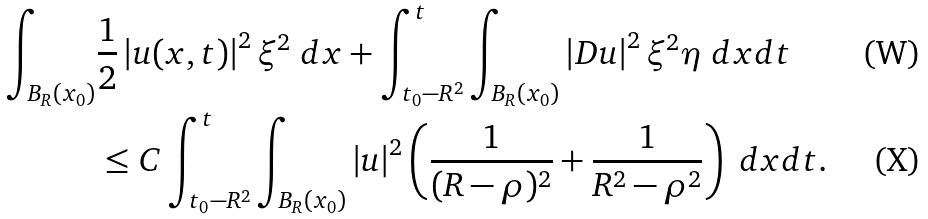Convert formula to latex. <formula><loc_0><loc_0><loc_500><loc_500>\int _ { B _ { R } ( x _ { 0 } ) } & \frac { 1 } { 2 } \left | u ( x , t ) \right | ^ { 2 } \xi ^ { 2 } \ d x + \int _ { t _ { 0 } - R ^ { 2 } } ^ { t } \int _ { B _ { R } ( x _ { 0 } ) } \left | D u \right | ^ { 2 } \xi ^ { 2 } \eta \ d x d t \\ & \leq C \int _ { t _ { 0 } - R ^ { 2 } } ^ { t } \int _ { B _ { R } ( x _ { 0 } ) } \left | u \right | ^ { 2 } \left ( \frac { 1 } { ( R - \rho ) ^ { 2 } } + \frac { 1 } { R ^ { 2 } - \rho ^ { 2 } } \right ) \ d x d t .</formula> 